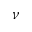Convert formula to latex. <formula><loc_0><loc_0><loc_500><loc_500>\nu</formula> 